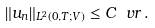<formula> <loc_0><loc_0><loc_500><loc_500>\| u _ { n } \| _ { L ^ { 2 } ( 0 , T ; V ) } \leq C _ { \ } v r \, .</formula> 